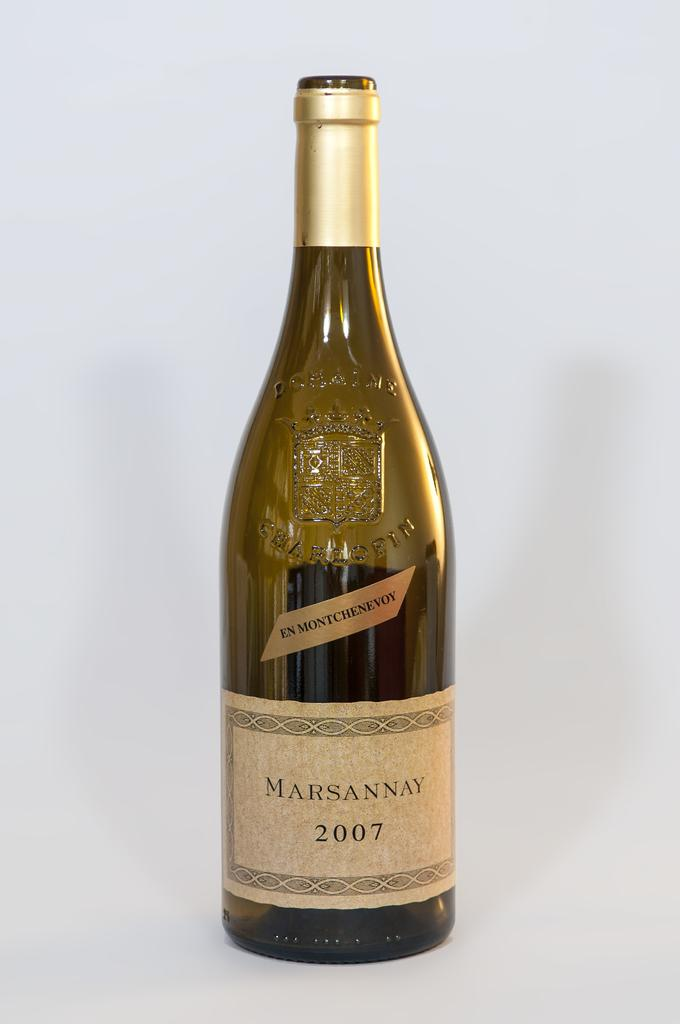<image>
Describe the image concisely. A bottle of Marsannay from 2007 against a white backdrop. 